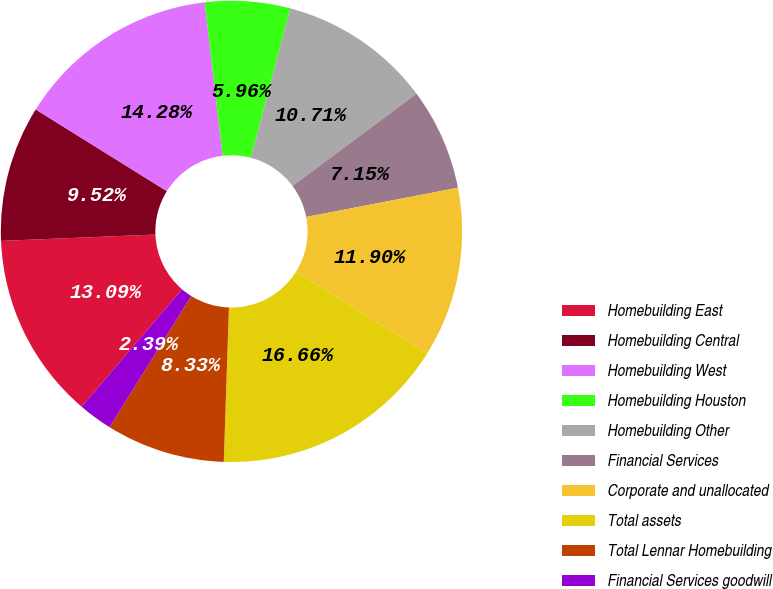Convert chart to OTSL. <chart><loc_0><loc_0><loc_500><loc_500><pie_chart><fcel>Homebuilding East<fcel>Homebuilding Central<fcel>Homebuilding West<fcel>Homebuilding Houston<fcel>Homebuilding Other<fcel>Financial Services<fcel>Corporate and unallocated<fcel>Total assets<fcel>Total Lennar Homebuilding<fcel>Financial Services goodwill<nl><fcel>13.09%<fcel>9.52%<fcel>14.28%<fcel>5.96%<fcel>10.71%<fcel>7.15%<fcel>11.9%<fcel>16.66%<fcel>8.33%<fcel>2.39%<nl></chart> 